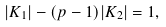<formula> <loc_0><loc_0><loc_500><loc_500>| K _ { 1 } | - ( p - 1 ) | K _ { 2 } | = 1 ,</formula> 